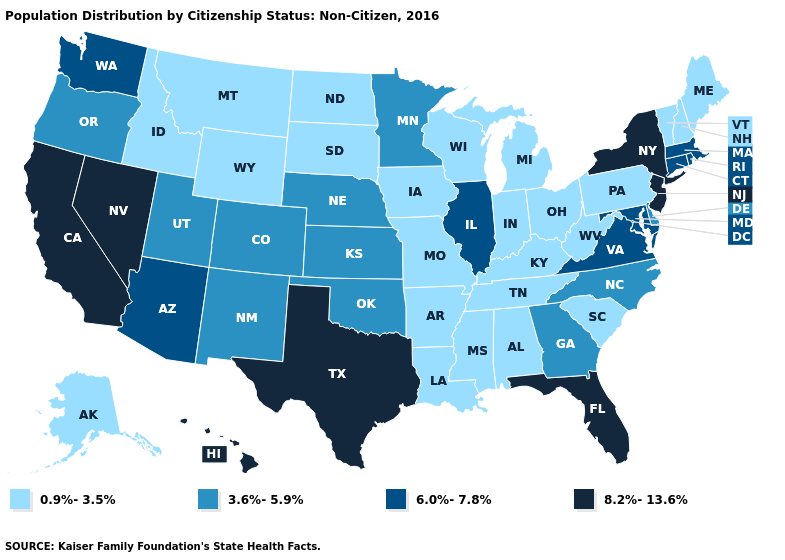What is the value of Washington?
Give a very brief answer. 6.0%-7.8%. What is the value of Wyoming?
Quick response, please. 0.9%-3.5%. Does Nevada have the same value as Florida?
Be succinct. Yes. What is the value of Alabama?
Be succinct. 0.9%-3.5%. What is the highest value in the USA?
Answer briefly. 8.2%-13.6%. Name the states that have a value in the range 6.0%-7.8%?
Be succinct. Arizona, Connecticut, Illinois, Maryland, Massachusetts, Rhode Island, Virginia, Washington. Does Arkansas have the highest value in the USA?
Concise answer only. No. Which states have the highest value in the USA?
Write a very short answer. California, Florida, Hawaii, Nevada, New Jersey, New York, Texas. What is the value of South Dakota?
Write a very short answer. 0.9%-3.5%. What is the value of Florida?
Short answer required. 8.2%-13.6%. Which states have the lowest value in the MidWest?
Short answer required. Indiana, Iowa, Michigan, Missouri, North Dakota, Ohio, South Dakota, Wisconsin. What is the lowest value in the West?
Answer briefly. 0.9%-3.5%. What is the value of Mississippi?
Write a very short answer. 0.9%-3.5%. Name the states that have a value in the range 3.6%-5.9%?
Be succinct. Colorado, Delaware, Georgia, Kansas, Minnesota, Nebraska, New Mexico, North Carolina, Oklahoma, Oregon, Utah. What is the value of Utah?
Be succinct. 3.6%-5.9%. 